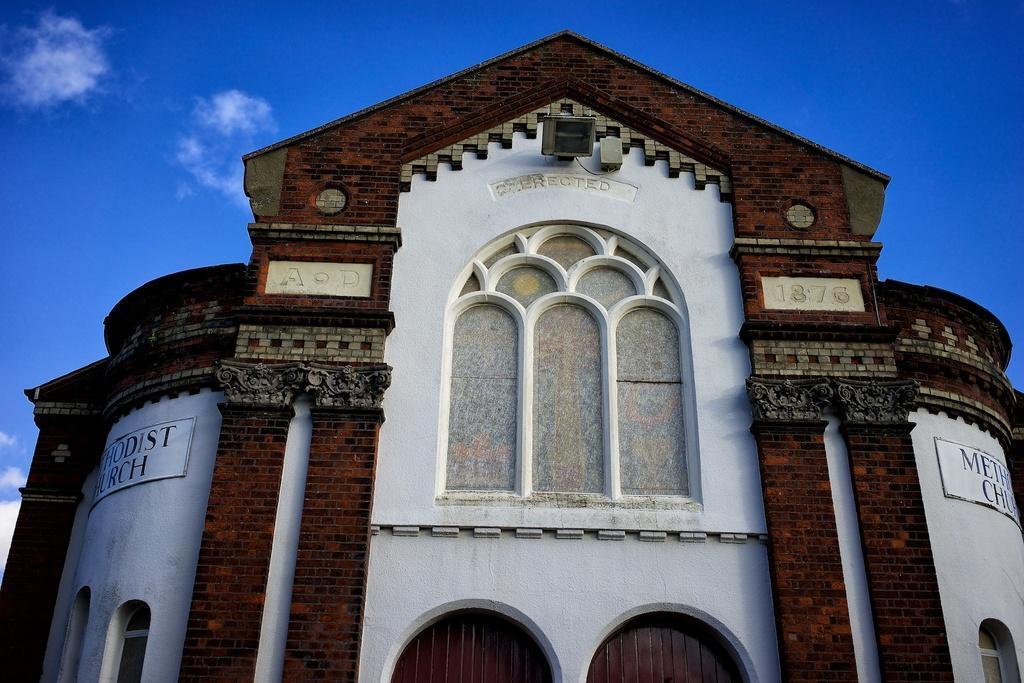Describe this image in one or two sentences. In this image there is a building in the middle. There is some text on the wall on either side of the building. At the top of the building there is a light. At the top there is the sky. 